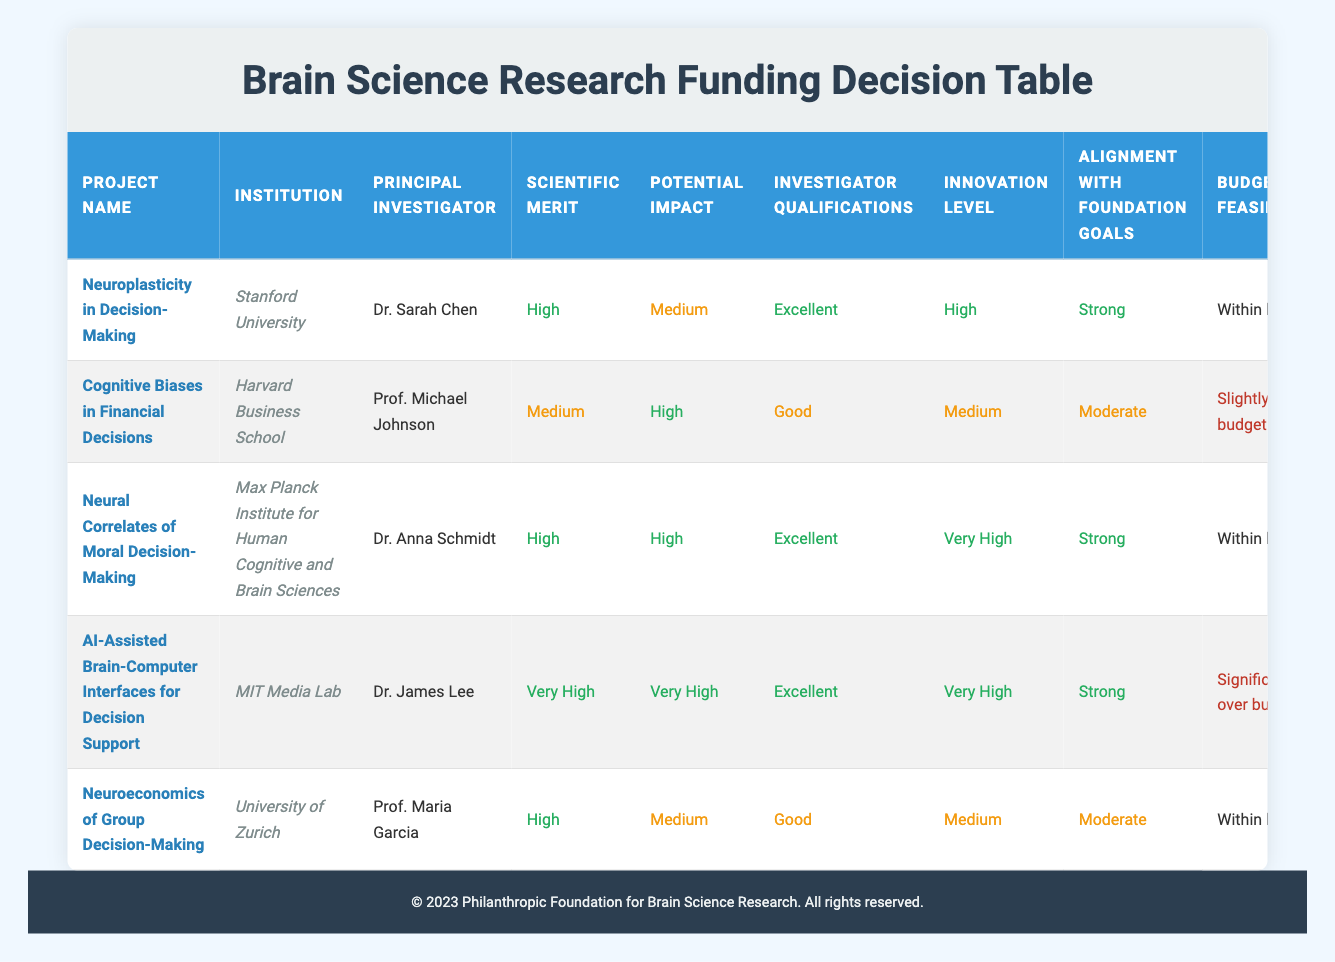What is the principal investigator's name for the project "AI-Assisted Brain-Computer Interfaces for Decision Support"? The principal investigator for the project "AI-Assisted Brain-Computer Interfaces for Decision Support" is listed in the table. By looking at the corresponding row, I find that it is Dr. James Lee.
Answer: Dr. James Lee Which project has the highest potential impact? To find the project with the highest potential impact, I need to compare the potential impact ratings of all projects. The ratings are either High or Very High. The project "AI-Assisted Brain-Computer Interfaces for Decision Support" has a potential impact of Very High, which is the highest rating on the table.
Answer: AI-Assisted Brain-Computer Interfaces for Decision Support How many projects have a budget feasibility classified as "Within limits"? I must count the number of projects with the budget feasibility status of "Within limits." Scanning through the table, I see that three projects—"Neuroplasticity in Decision-Making," "Neural Correlates of Moral Decision-Making," and "Neuroeconomics of Group Decision-Making"—have this classification.
Answer: 3 Is the innovation level for "Cognitive Biases in Financial Decisions" rated as "High"? I check the row corresponding to "Cognitive Biases in Financial Decisions" for its innovation level. The table clearly shows that the innovation level for this project is rated as Medium, not High.
Answer: No What is the average scientific merit rating for the projects listed? To find the average scientific merit, I assign numerical values to the ratings: Very High = 4, High = 3, Medium = 2, Low = 1. The scientific merit ratings for the projects are: Very High (1), High (3), Medium (1), High (3), High (3). Therefore, the sum is 4 + 3 + 2 + 3 + 3 = 15, and dividing it by 5 (the number of projects) gives an average of 3.
Answer: 3 Which project has the lowest collaboration potential? Examining the collaboration potential column, I need to identify which project has the lowest rating. In this table, "Cognitive Biases in Financial Decisions" has a collaboration potential rated as Medium, whereas others are either High or Very High. No project is rated lower than Medium in this category, making this the lowest.
Answer: Cognitive Biases in Financial Decisions Are there any projects with both "Significantly over budget" and "Very High" potential impact? To answer, I look for rows where the budget feasibility is classified as "Significantly over budget" and check the corresponding potential impact. The project "AI-Assisted Brain-Computer Interfaces for Decision Support" fits this criterion with a status of "Significantly over budget" and a potential impact of "Very High." Hence, at least one such project exists.
Answer: Yes What is the total number of projects rated with "Excellent" investigator qualifications? In the table, I filter for the "Investigator Qualifications" column to count the projects rated as "Excellent." The projects "Neuroplasticity in Decision-Making," "Neural Correlates of Moral Decision-Making," and "AI-Assisted Brain-Computer Interfaces for Decision Support" all have "Excellent" qualifications, leading to a total of three.
Answer: 3 